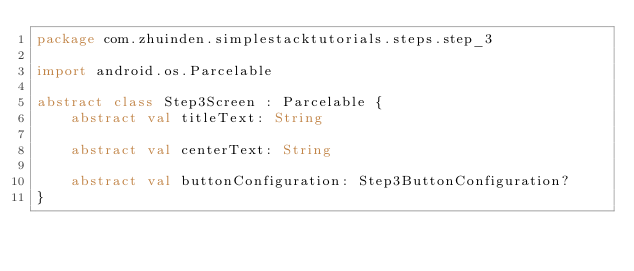<code> <loc_0><loc_0><loc_500><loc_500><_Kotlin_>package com.zhuinden.simplestacktutorials.steps.step_3

import android.os.Parcelable

abstract class Step3Screen : Parcelable {
    abstract val titleText: String

    abstract val centerText: String

    abstract val buttonConfiguration: Step3ButtonConfiguration?
}</code> 